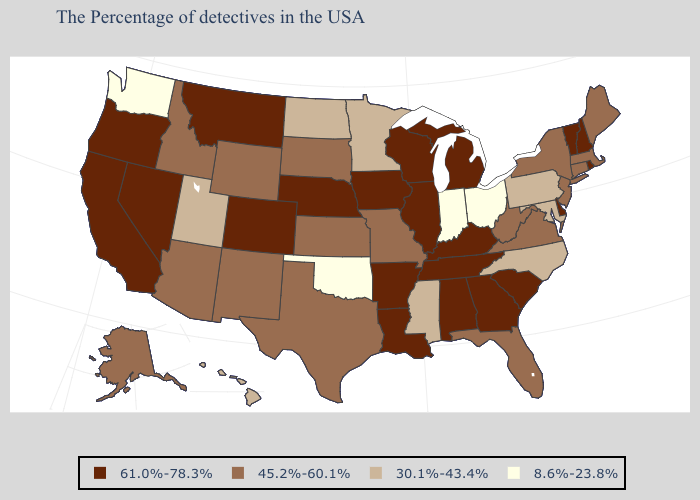Does Vermont have the highest value in the USA?
Write a very short answer. Yes. Does West Virginia have the highest value in the USA?
Give a very brief answer. No. Which states have the lowest value in the USA?
Concise answer only. Ohio, Indiana, Oklahoma, Washington. Among the states that border Utah , which have the lowest value?
Concise answer only. Wyoming, New Mexico, Arizona, Idaho. What is the lowest value in states that border Texas?
Answer briefly. 8.6%-23.8%. Which states have the lowest value in the USA?
Give a very brief answer. Ohio, Indiana, Oklahoma, Washington. What is the lowest value in the West?
Write a very short answer. 8.6%-23.8%. Does the first symbol in the legend represent the smallest category?
Write a very short answer. No. What is the value of Illinois?
Write a very short answer. 61.0%-78.3%. Name the states that have a value in the range 8.6%-23.8%?
Write a very short answer. Ohio, Indiana, Oklahoma, Washington. Among the states that border Florida , which have the highest value?
Short answer required. Georgia, Alabama. What is the lowest value in the USA?
Keep it brief. 8.6%-23.8%. Which states have the lowest value in the West?
Write a very short answer. Washington. Does Virginia have the highest value in the South?
Short answer required. No. What is the value of Ohio?
Short answer required. 8.6%-23.8%. 